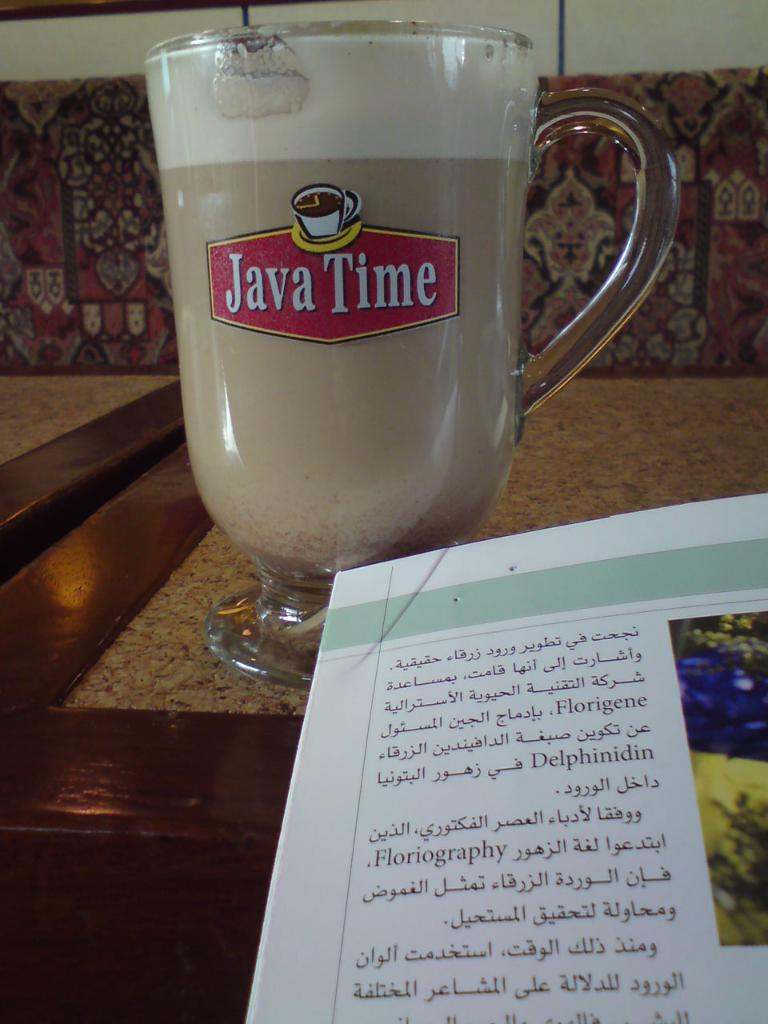What is written on the glass in the image? "Java Time" is written on the glass in the image. What else can be seen in the image besides the glass? There is a paper in the image. What type of science experiment is being conducted in the image? There is no science experiment present in the image; it only features a glass with "Java Time" written on it and a paper. 